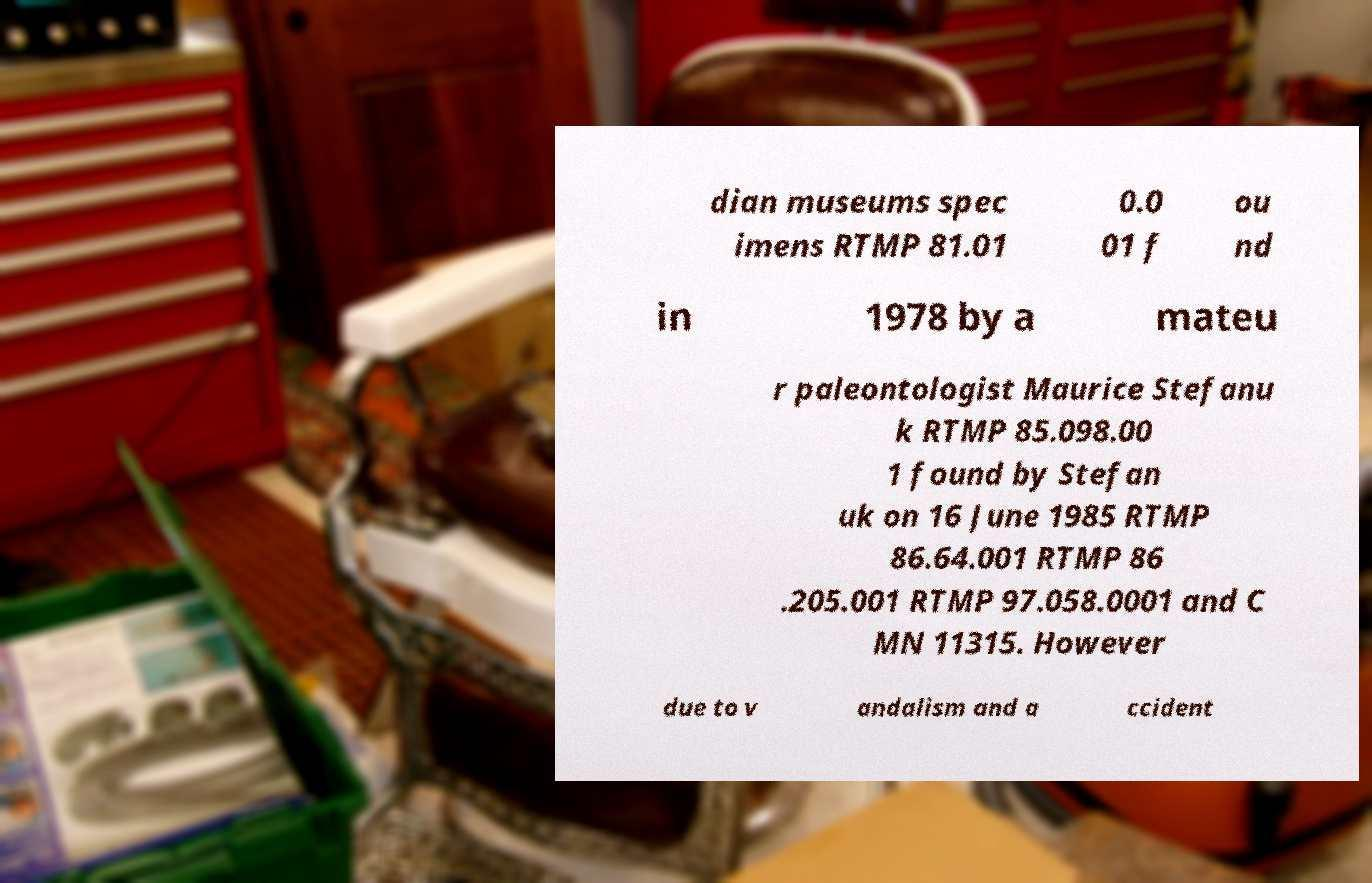Could you extract and type out the text from this image? dian museums spec imens RTMP 81.01 0.0 01 f ou nd in 1978 by a mateu r paleontologist Maurice Stefanu k RTMP 85.098.00 1 found by Stefan uk on 16 June 1985 RTMP 86.64.001 RTMP 86 .205.001 RTMP 97.058.0001 and C MN 11315. However due to v andalism and a ccident 